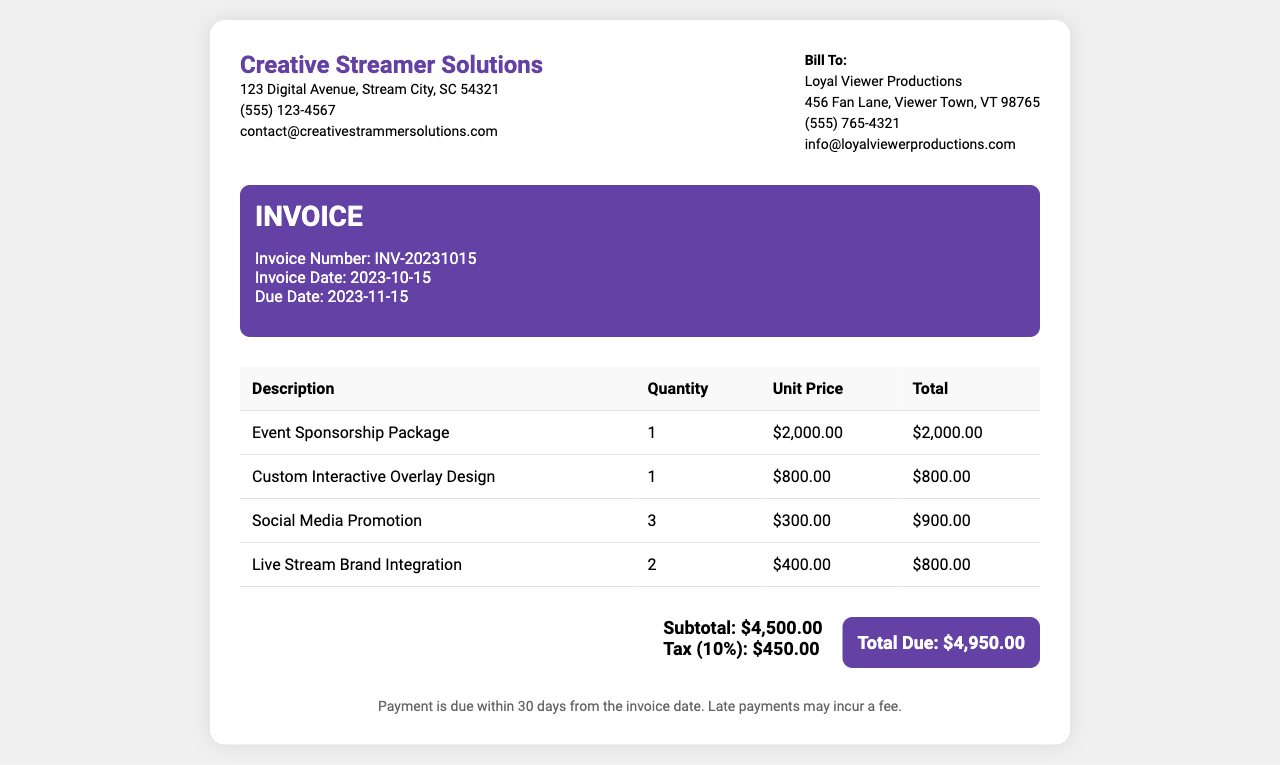What is the invoice number? The invoice number is listed in the invoice details section.
Answer: INV-20231015 What is the total due amount? The total due amount is specified in the total section of the invoice.
Answer: $4,950.00 What is the quantity for the Social Media Promotion? The quantity for Social Media Promotion is provided in the itemized list of services.
Answer: 3 What is the unit price of the Custom Interactive Overlay Design? The unit price is mentioned in the invoice's itemized table.
Answer: $800.00 When is the due date for the payment? The due date is listed in the invoice details section.
Answer: 2023-11-15 What percentage is the tax applied to the subtotal? The tax percentage is indicated alongside the tax amount in the total section.
Answer: 10% How many Live Stream Brand Integrations are included? The included quantity is shown in the itemized list of services provided in the document.
Answer: 2 Who is the invoice billed to? The billing information is detailed in the client info section of the invoice.
Answer: Loyal Viewer Productions What is the subtotal amount before tax? The subtotal amount is displayed in the total section of the invoice.
Answer: $4,500.00 